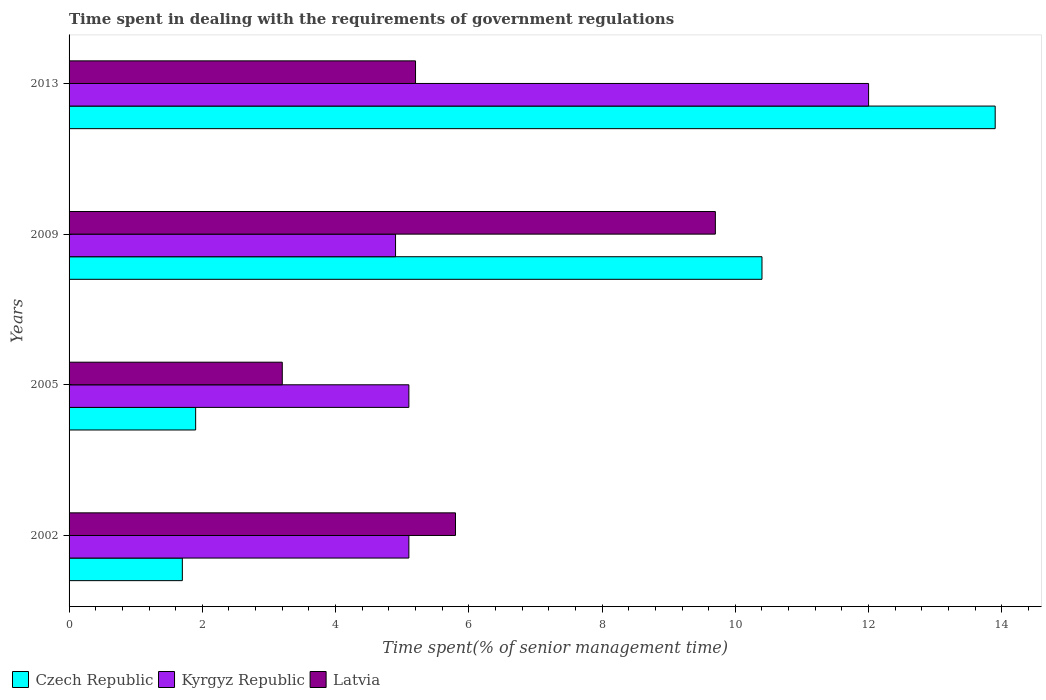How many groups of bars are there?
Make the answer very short. 4. Are the number of bars per tick equal to the number of legend labels?
Ensure brevity in your answer.  Yes. How many bars are there on the 4th tick from the top?
Make the answer very short. 3. How many bars are there on the 2nd tick from the bottom?
Your answer should be compact. 3. In how many cases, is the number of bars for a given year not equal to the number of legend labels?
Offer a very short reply. 0. What is the time spent while dealing with the requirements of government regulations in Czech Republic in 2009?
Your answer should be very brief. 10.4. In which year was the time spent while dealing with the requirements of government regulations in Czech Republic maximum?
Keep it short and to the point. 2013. In which year was the time spent while dealing with the requirements of government regulations in Kyrgyz Republic minimum?
Make the answer very short. 2009. What is the total time spent while dealing with the requirements of government regulations in Kyrgyz Republic in the graph?
Keep it short and to the point. 27.1. What is the difference between the time spent while dealing with the requirements of government regulations in Czech Republic in 2009 and the time spent while dealing with the requirements of government regulations in Kyrgyz Republic in 2013?
Your response must be concise. -1.6. What is the average time spent while dealing with the requirements of government regulations in Czech Republic per year?
Make the answer very short. 6.97. In the year 2002, what is the difference between the time spent while dealing with the requirements of government regulations in Latvia and time spent while dealing with the requirements of government regulations in Kyrgyz Republic?
Offer a terse response. 0.7. What is the ratio of the time spent while dealing with the requirements of government regulations in Latvia in 2002 to that in 2009?
Provide a short and direct response. 0.6. What is the difference between the highest and the second highest time spent while dealing with the requirements of government regulations in Latvia?
Your answer should be compact. 3.9. What is the difference between the highest and the lowest time spent while dealing with the requirements of government regulations in Czech Republic?
Offer a terse response. 12.2. In how many years, is the time spent while dealing with the requirements of government regulations in Kyrgyz Republic greater than the average time spent while dealing with the requirements of government regulations in Kyrgyz Republic taken over all years?
Keep it short and to the point. 1. Is the sum of the time spent while dealing with the requirements of government regulations in Kyrgyz Republic in 2002 and 2009 greater than the maximum time spent while dealing with the requirements of government regulations in Czech Republic across all years?
Offer a very short reply. No. What does the 1st bar from the top in 2005 represents?
Provide a short and direct response. Latvia. What does the 2nd bar from the bottom in 2013 represents?
Provide a short and direct response. Kyrgyz Republic. Is it the case that in every year, the sum of the time spent while dealing with the requirements of government regulations in Czech Republic and time spent while dealing with the requirements of government regulations in Latvia is greater than the time spent while dealing with the requirements of government regulations in Kyrgyz Republic?
Offer a very short reply. No. What is the difference between two consecutive major ticks on the X-axis?
Your response must be concise. 2. Does the graph contain any zero values?
Your answer should be very brief. No. Where does the legend appear in the graph?
Your answer should be compact. Bottom left. How many legend labels are there?
Make the answer very short. 3. How are the legend labels stacked?
Provide a short and direct response. Horizontal. What is the title of the graph?
Provide a short and direct response. Time spent in dealing with the requirements of government regulations. Does "Algeria" appear as one of the legend labels in the graph?
Give a very brief answer. No. What is the label or title of the X-axis?
Provide a short and direct response. Time spent(% of senior management time). What is the Time spent(% of senior management time) in Latvia in 2002?
Offer a very short reply. 5.8. What is the Time spent(% of senior management time) in Czech Republic in 2005?
Make the answer very short. 1.9. What is the Time spent(% of senior management time) of Kyrgyz Republic in 2005?
Provide a short and direct response. 5.1. What is the Time spent(% of senior management time) of Latvia in 2005?
Offer a very short reply. 3.2. What is the Time spent(% of senior management time) in Czech Republic in 2009?
Ensure brevity in your answer.  10.4. What is the Time spent(% of senior management time) of Kyrgyz Republic in 2009?
Your answer should be very brief. 4.9. What is the Time spent(% of senior management time) of Latvia in 2009?
Provide a short and direct response. 9.7. What is the Time spent(% of senior management time) in Czech Republic in 2013?
Provide a succinct answer. 13.9. What is the Time spent(% of senior management time) of Kyrgyz Republic in 2013?
Make the answer very short. 12. What is the total Time spent(% of senior management time) of Czech Republic in the graph?
Your answer should be very brief. 27.9. What is the total Time spent(% of senior management time) of Kyrgyz Republic in the graph?
Give a very brief answer. 27.1. What is the total Time spent(% of senior management time) of Latvia in the graph?
Ensure brevity in your answer.  23.9. What is the difference between the Time spent(% of senior management time) of Czech Republic in 2002 and that in 2005?
Offer a very short reply. -0.2. What is the difference between the Time spent(% of senior management time) in Kyrgyz Republic in 2002 and that in 2005?
Offer a very short reply. 0. What is the difference between the Time spent(% of senior management time) in Latvia in 2002 and that in 2005?
Make the answer very short. 2.6. What is the difference between the Time spent(% of senior management time) in Kyrgyz Republic in 2002 and that in 2009?
Your response must be concise. 0.2. What is the difference between the Time spent(% of senior management time) of Latvia in 2002 and that in 2009?
Keep it short and to the point. -3.9. What is the difference between the Time spent(% of senior management time) of Kyrgyz Republic in 2002 and that in 2013?
Ensure brevity in your answer.  -6.9. What is the difference between the Time spent(% of senior management time) in Czech Republic in 2005 and that in 2009?
Your answer should be compact. -8.5. What is the difference between the Time spent(% of senior management time) in Czech Republic in 2005 and that in 2013?
Ensure brevity in your answer.  -12. What is the difference between the Time spent(% of senior management time) of Kyrgyz Republic in 2005 and that in 2013?
Provide a short and direct response. -6.9. What is the difference between the Time spent(% of senior management time) in Latvia in 2005 and that in 2013?
Your response must be concise. -2. What is the difference between the Time spent(% of senior management time) in Czech Republic in 2009 and that in 2013?
Offer a terse response. -3.5. What is the difference between the Time spent(% of senior management time) in Kyrgyz Republic in 2009 and that in 2013?
Your answer should be very brief. -7.1. What is the difference between the Time spent(% of senior management time) in Latvia in 2009 and that in 2013?
Offer a very short reply. 4.5. What is the difference between the Time spent(% of senior management time) in Czech Republic in 2002 and the Time spent(% of senior management time) in Latvia in 2005?
Provide a succinct answer. -1.5. What is the difference between the Time spent(% of senior management time) in Kyrgyz Republic in 2002 and the Time spent(% of senior management time) in Latvia in 2005?
Provide a succinct answer. 1.9. What is the difference between the Time spent(% of senior management time) of Czech Republic in 2002 and the Time spent(% of senior management time) of Kyrgyz Republic in 2009?
Provide a succinct answer. -3.2. What is the difference between the Time spent(% of senior management time) of Czech Republic in 2002 and the Time spent(% of senior management time) of Latvia in 2009?
Offer a terse response. -8. What is the difference between the Time spent(% of senior management time) in Czech Republic in 2002 and the Time spent(% of senior management time) in Latvia in 2013?
Your answer should be compact. -3.5. What is the difference between the Time spent(% of senior management time) of Kyrgyz Republic in 2002 and the Time spent(% of senior management time) of Latvia in 2013?
Provide a succinct answer. -0.1. What is the difference between the Time spent(% of senior management time) of Czech Republic in 2005 and the Time spent(% of senior management time) of Latvia in 2009?
Ensure brevity in your answer.  -7.8. What is the difference between the Time spent(% of senior management time) in Kyrgyz Republic in 2005 and the Time spent(% of senior management time) in Latvia in 2009?
Provide a short and direct response. -4.6. What is the difference between the Time spent(% of senior management time) in Czech Republic in 2005 and the Time spent(% of senior management time) in Latvia in 2013?
Your answer should be very brief. -3.3. What is the difference between the Time spent(% of senior management time) in Czech Republic in 2009 and the Time spent(% of senior management time) in Latvia in 2013?
Provide a succinct answer. 5.2. What is the average Time spent(% of senior management time) in Czech Republic per year?
Your response must be concise. 6.97. What is the average Time spent(% of senior management time) in Kyrgyz Republic per year?
Your answer should be compact. 6.78. What is the average Time spent(% of senior management time) in Latvia per year?
Your answer should be compact. 5.97. In the year 2005, what is the difference between the Time spent(% of senior management time) of Czech Republic and Time spent(% of senior management time) of Latvia?
Offer a very short reply. -1.3. In the year 2005, what is the difference between the Time spent(% of senior management time) of Kyrgyz Republic and Time spent(% of senior management time) of Latvia?
Your response must be concise. 1.9. In the year 2009, what is the difference between the Time spent(% of senior management time) in Kyrgyz Republic and Time spent(% of senior management time) in Latvia?
Ensure brevity in your answer.  -4.8. In the year 2013, what is the difference between the Time spent(% of senior management time) of Czech Republic and Time spent(% of senior management time) of Latvia?
Ensure brevity in your answer.  8.7. What is the ratio of the Time spent(% of senior management time) in Czech Republic in 2002 to that in 2005?
Keep it short and to the point. 0.89. What is the ratio of the Time spent(% of senior management time) of Kyrgyz Republic in 2002 to that in 2005?
Provide a short and direct response. 1. What is the ratio of the Time spent(% of senior management time) in Latvia in 2002 to that in 2005?
Ensure brevity in your answer.  1.81. What is the ratio of the Time spent(% of senior management time) in Czech Republic in 2002 to that in 2009?
Offer a very short reply. 0.16. What is the ratio of the Time spent(% of senior management time) in Kyrgyz Republic in 2002 to that in 2009?
Keep it short and to the point. 1.04. What is the ratio of the Time spent(% of senior management time) in Latvia in 2002 to that in 2009?
Give a very brief answer. 0.6. What is the ratio of the Time spent(% of senior management time) in Czech Republic in 2002 to that in 2013?
Give a very brief answer. 0.12. What is the ratio of the Time spent(% of senior management time) in Kyrgyz Republic in 2002 to that in 2013?
Provide a short and direct response. 0.42. What is the ratio of the Time spent(% of senior management time) in Latvia in 2002 to that in 2013?
Ensure brevity in your answer.  1.12. What is the ratio of the Time spent(% of senior management time) of Czech Republic in 2005 to that in 2009?
Ensure brevity in your answer.  0.18. What is the ratio of the Time spent(% of senior management time) of Kyrgyz Republic in 2005 to that in 2009?
Keep it short and to the point. 1.04. What is the ratio of the Time spent(% of senior management time) of Latvia in 2005 to that in 2009?
Offer a terse response. 0.33. What is the ratio of the Time spent(% of senior management time) in Czech Republic in 2005 to that in 2013?
Provide a short and direct response. 0.14. What is the ratio of the Time spent(% of senior management time) in Kyrgyz Republic in 2005 to that in 2013?
Ensure brevity in your answer.  0.42. What is the ratio of the Time spent(% of senior management time) of Latvia in 2005 to that in 2013?
Offer a terse response. 0.62. What is the ratio of the Time spent(% of senior management time) of Czech Republic in 2009 to that in 2013?
Your response must be concise. 0.75. What is the ratio of the Time spent(% of senior management time) in Kyrgyz Republic in 2009 to that in 2013?
Your answer should be very brief. 0.41. What is the ratio of the Time spent(% of senior management time) in Latvia in 2009 to that in 2013?
Offer a terse response. 1.87. 